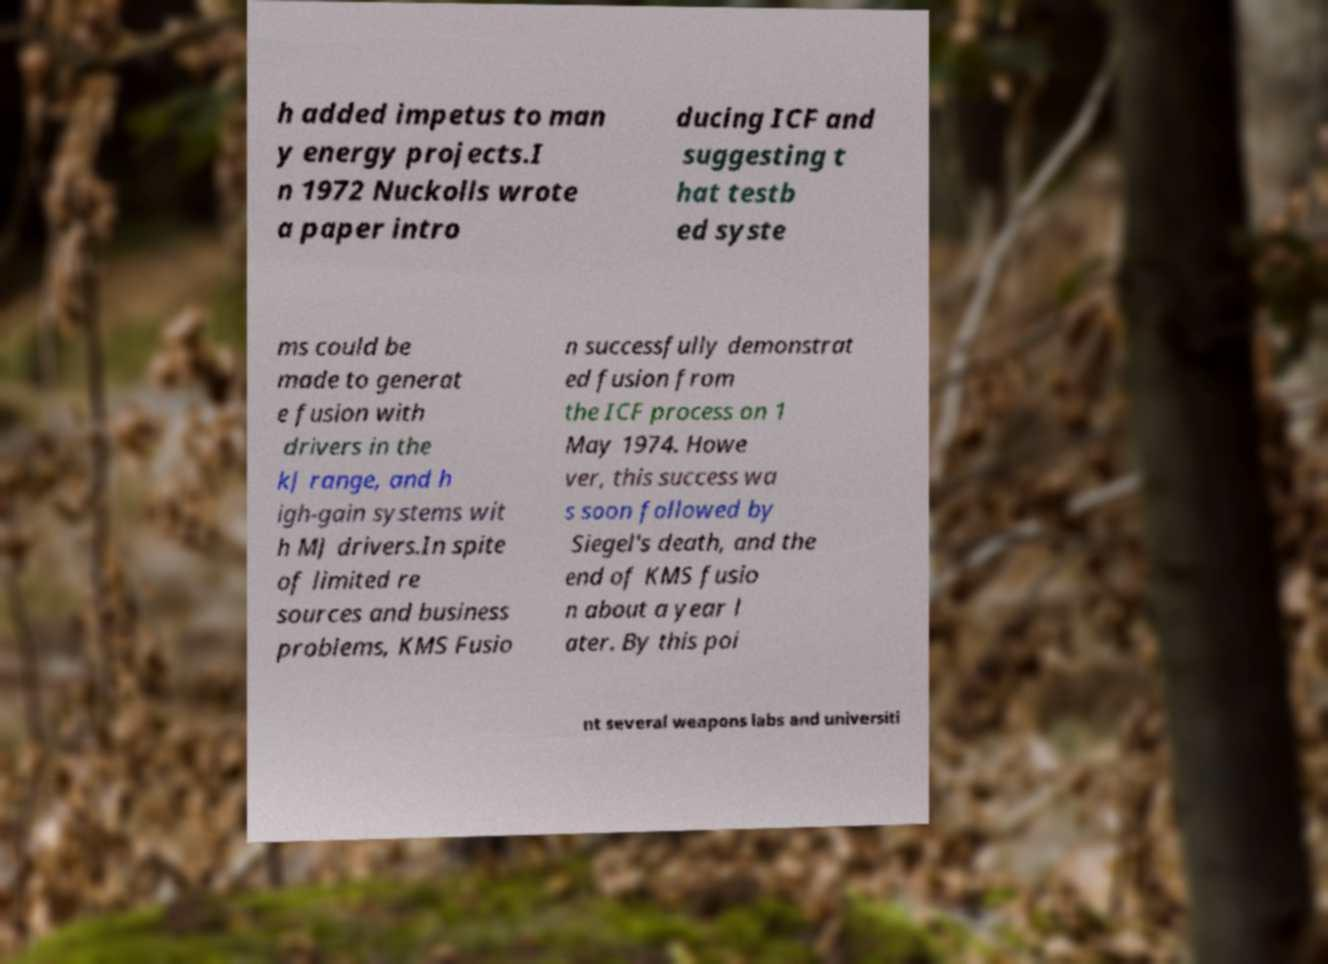Could you extract and type out the text from this image? h added impetus to man y energy projects.I n 1972 Nuckolls wrote a paper intro ducing ICF and suggesting t hat testb ed syste ms could be made to generat e fusion with drivers in the kJ range, and h igh-gain systems wit h MJ drivers.In spite of limited re sources and business problems, KMS Fusio n successfully demonstrat ed fusion from the ICF process on 1 May 1974. Howe ver, this success wa s soon followed by Siegel's death, and the end of KMS fusio n about a year l ater. By this poi nt several weapons labs and universiti 